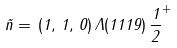<formula> <loc_0><loc_0><loc_500><loc_500>\vec { n } = \, ( 1 , \, 1 , \, 0 ) \, \Lambda ( 1 1 1 9 ) \, \frac { 1 } { 2 } ^ { + }</formula> 